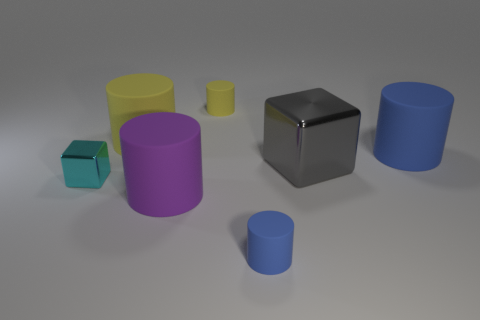Are there any other things that have the same size as the gray thing?
Provide a succinct answer. Yes. Is there any other thing that has the same shape as the purple matte thing?
Give a very brief answer. Yes. There is a tiny object that is on the right side of the tiny cyan thing and on the left side of the tiny blue rubber cylinder; what shape is it?
Ensure brevity in your answer.  Cylinder. What shape is the large gray object that is made of the same material as the tiny cyan cube?
Offer a terse response. Cube. Are any yellow cylinders visible?
Offer a terse response. Yes. Is there a large blue cylinder right of the blue thing that is behind the big gray metallic thing?
Give a very brief answer. No. There is another cyan object that is the same shape as the big metal object; what is it made of?
Keep it short and to the point. Metal. Are there more purple matte cylinders than large yellow cubes?
Your response must be concise. Yes. Is the color of the large metal block the same as the large rubber thing that is in front of the tiny cyan shiny cube?
Your response must be concise. No. There is a small object that is both behind the big purple thing and right of the cyan metal cube; what color is it?
Offer a terse response. Yellow. 